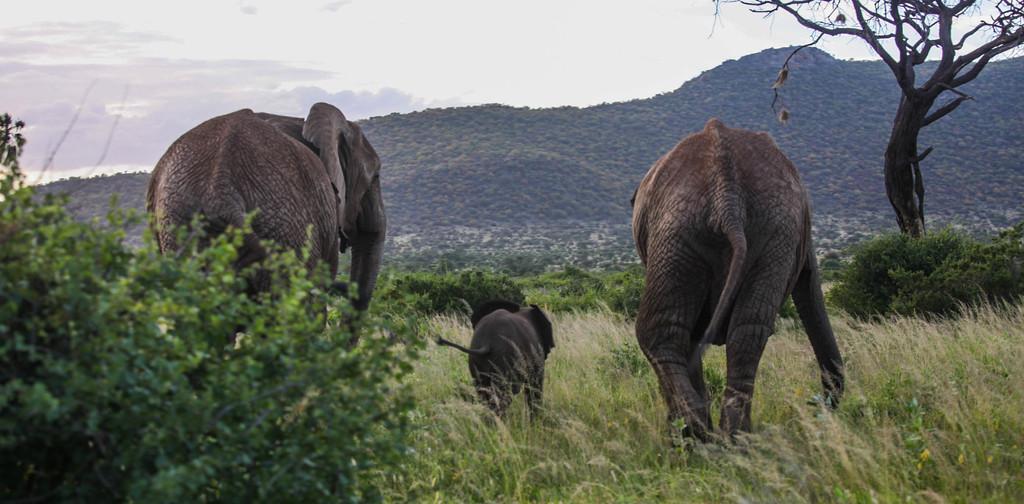In one or two sentences, can you explain what this image depicts? In this image we can see two elephants and a calf in the middle. We can see the hills, grass and trees. At the top we can see the clouds in the sky. 